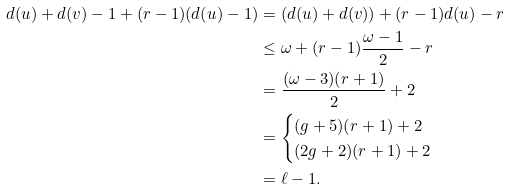Convert formula to latex. <formula><loc_0><loc_0><loc_500><loc_500>d ( u ) + d ( v ) - 1 + ( r - 1 ) ( d ( u ) - 1 ) & = ( d ( u ) + d ( v ) ) + ( r - 1 ) d ( u ) - r \\ & \leq \omega + ( r - 1 ) \frac { \omega - 1 } { 2 } - r \\ & = \frac { ( \omega - 3 ) ( r + 1 ) } { 2 } + 2 \\ & = \begin{cases} ( g + 5 ) ( r + 1 ) + 2 & \\ ( 2 g + 2 ) ( r + 1 ) + 2 & \end{cases} \\ & = \ell - 1 .</formula> 